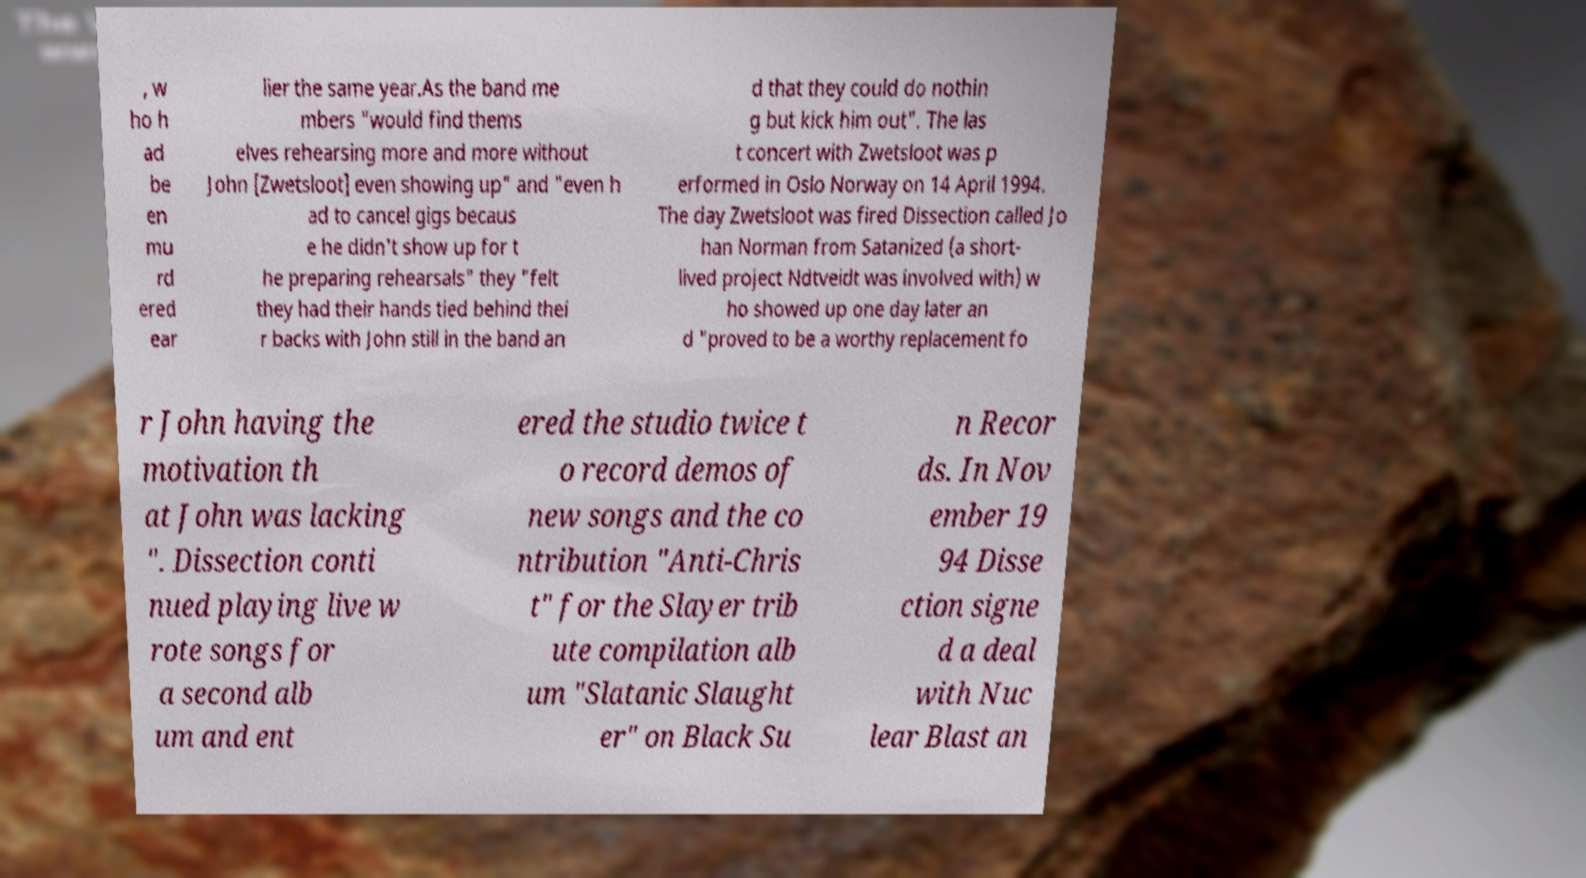Can you accurately transcribe the text from the provided image for me? , w ho h ad be en mu rd ered ear lier the same year.As the band me mbers "would find thems elves rehearsing more and more without John [Zwetsloot] even showing up" and "even h ad to cancel gigs becaus e he didn't show up for t he preparing rehearsals" they "felt they had their hands tied behind thei r backs with John still in the band an d that they could do nothin g but kick him out". The las t concert with Zwetsloot was p erformed in Oslo Norway on 14 April 1994. The day Zwetsloot was fired Dissection called Jo han Norman from Satanized (a short- lived project Ndtveidt was involved with) w ho showed up one day later an d "proved to be a worthy replacement fo r John having the motivation th at John was lacking ". Dissection conti nued playing live w rote songs for a second alb um and ent ered the studio twice t o record demos of new songs and the co ntribution "Anti-Chris t" for the Slayer trib ute compilation alb um "Slatanic Slaught er" on Black Su n Recor ds. In Nov ember 19 94 Disse ction signe d a deal with Nuc lear Blast an 